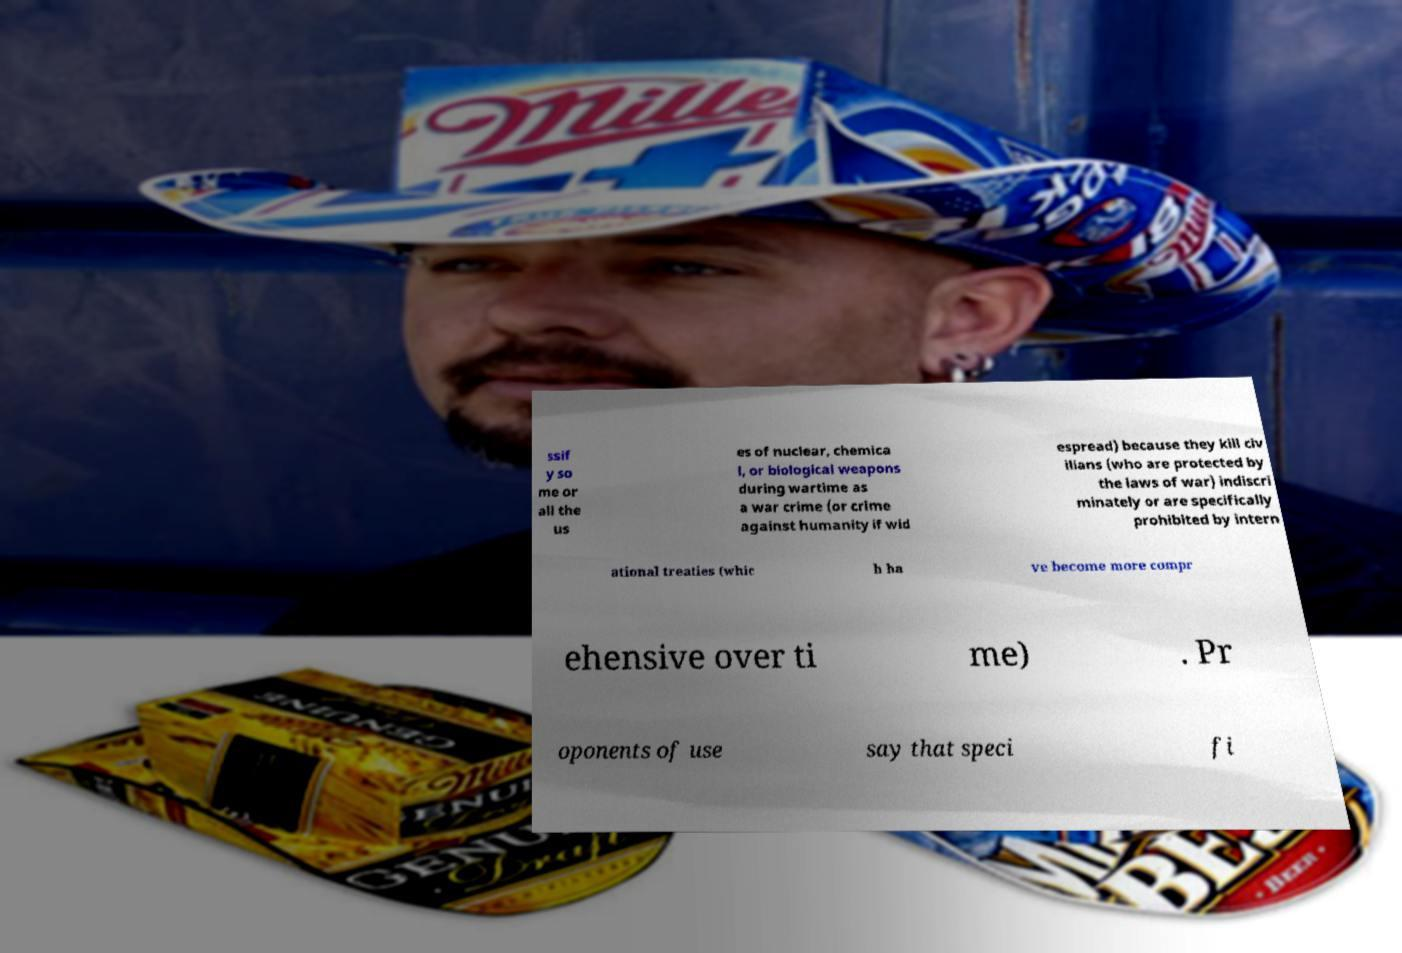For documentation purposes, I need the text within this image transcribed. Could you provide that? ssif y so me or all the us es of nuclear, chemica l, or biological weapons during wartime as a war crime (or crime against humanity if wid espread) because they kill civ ilians (who are protected by the laws of war) indiscri minately or are specifically prohibited by intern ational treaties (whic h ha ve become more compr ehensive over ti me) . Pr oponents of use say that speci fi 